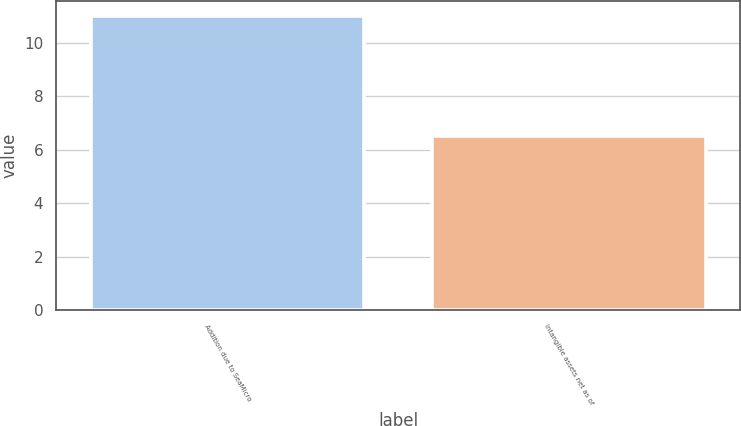<chart> <loc_0><loc_0><loc_500><loc_500><bar_chart><fcel>Addition due to SeaMicro<fcel>Intangible assets net as of<nl><fcel>11<fcel>6.5<nl></chart> 